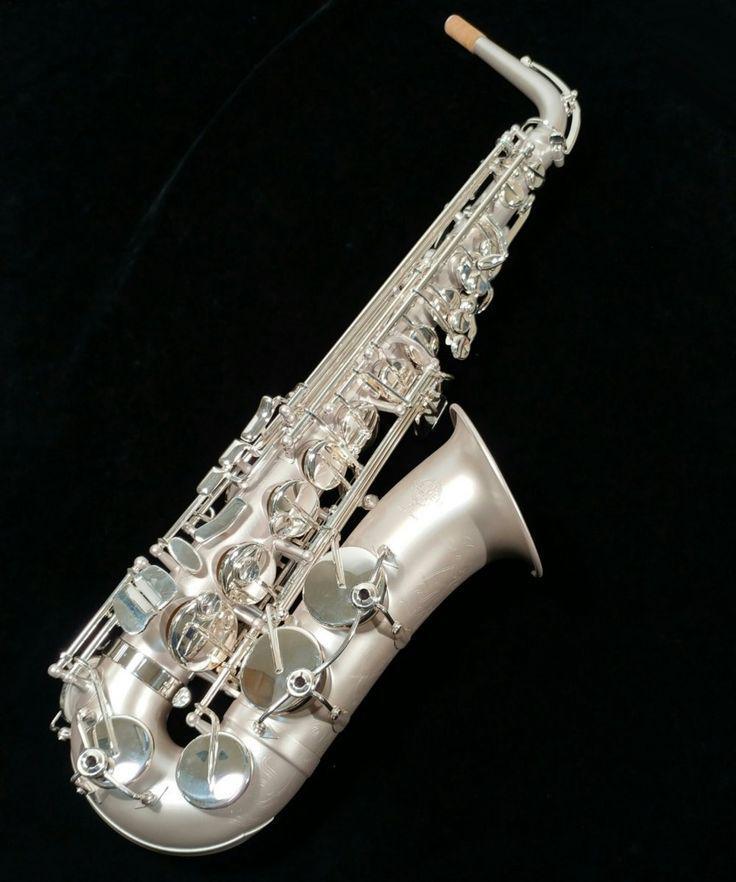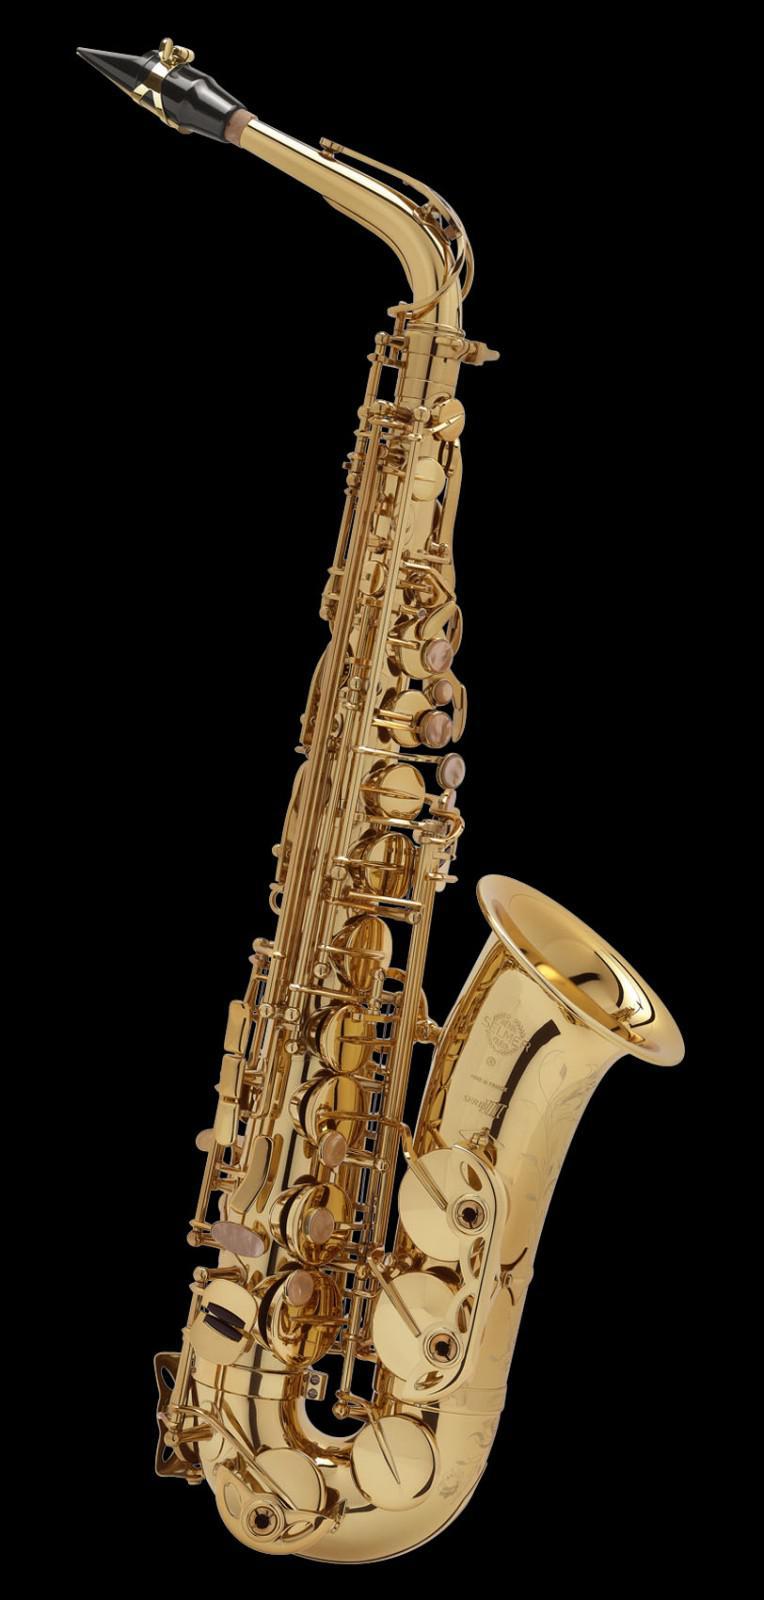The first image is the image on the left, the second image is the image on the right. Analyze the images presented: Is the assertion "Exactly two saxophones are shown, the same color, but angled differently at the mouthpiece area." valid? Answer yes or no. No. The first image is the image on the left, the second image is the image on the right. Analyze the images presented: Is the assertion "Each image contains one saxophone displayed at some angle, with its bell facing rightward, and one image features a silver saxophone with a brown tip at one end." valid? Answer yes or no. Yes. 